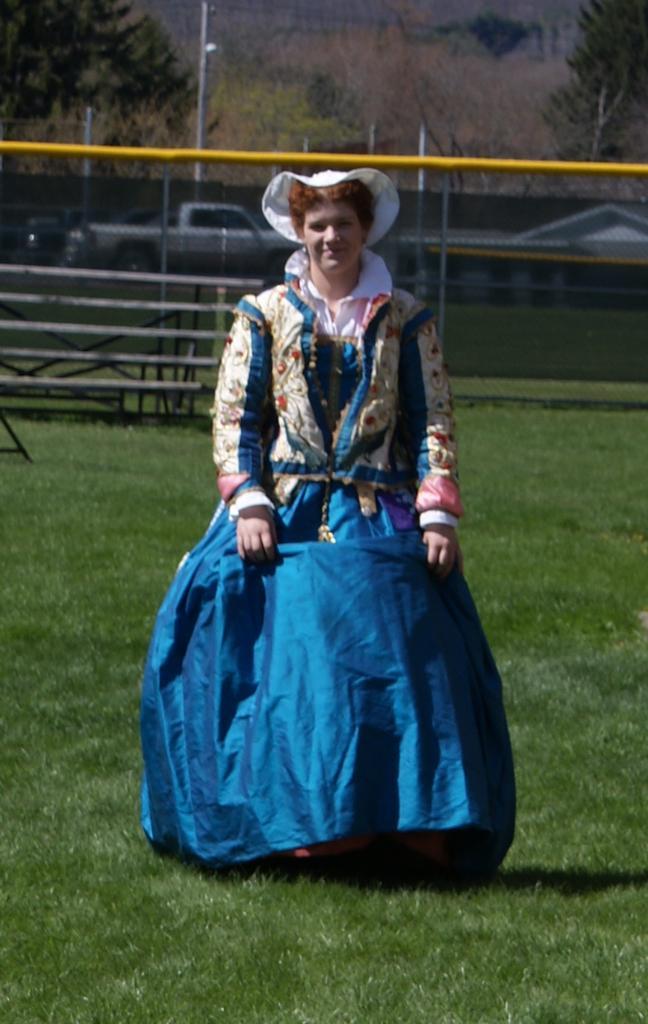Can you describe this image briefly? In the image I can see a person who is wearing different costume and behind there are some trees, fencing and some poles. 